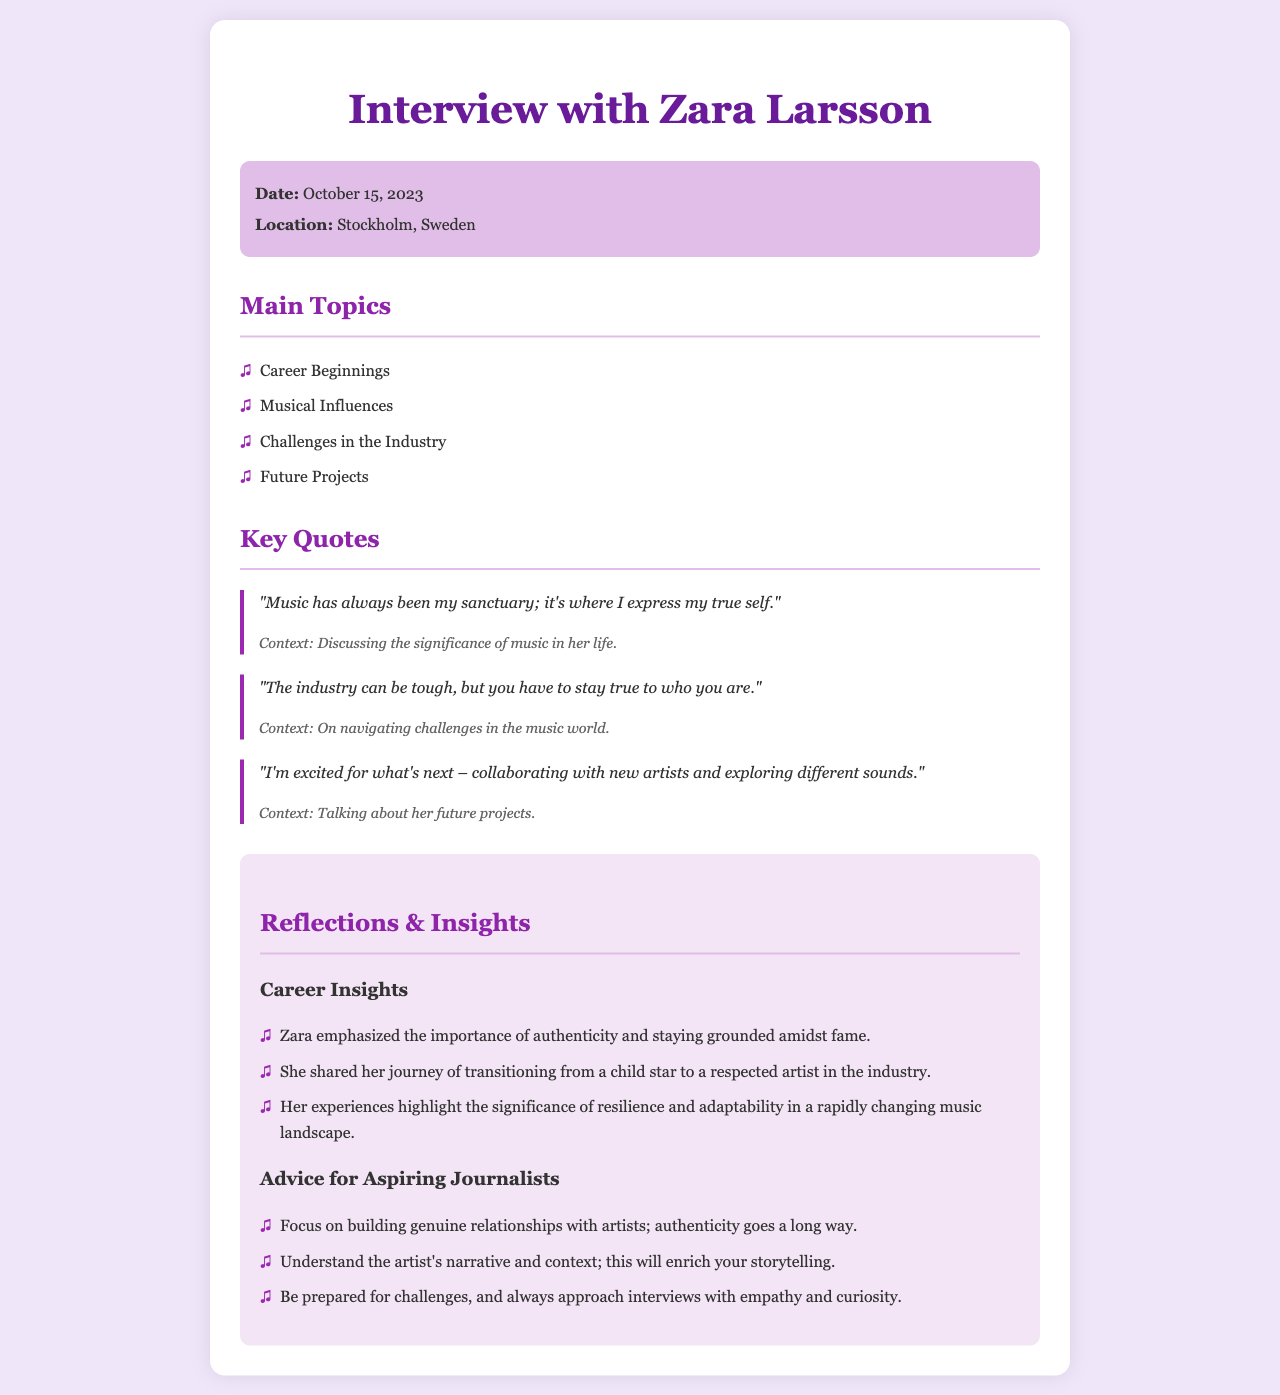What is the date of the interview? The date of the interview can be found in the document's interview details section, which states it took place on October 15, 2023.
Answer: October 15, 2023 Where was the interview conducted? The location of the interview is provided in the document, specifically noting it took place in Stockholm, Sweden.
Answer: Stockholm, Sweden What is one of the main topics discussed in the interview? The main topics are outlined in a list in the document; one of the topics is "Career Beginnings."
Answer: Career Beginnings What does Zara say about music in her life? Her view on music is captured in a quote, indicating its importance as her sanctuary and a means of self-expression.
Answer: "Music has always been my sanctuary; it's where I express my true self." What key advice does Zara give for aspiring journalists? The reflections section contains advice from Zara, emphasizing the importance of building genuine relationships with artists.
Answer: Build genuine relationships How does Zara describe the music industry? She discusses the challenges of the industry in her quotes, highlighting the need to stay true to oneself.
Answer: The industry can be tough What future projects is Zara excited about? In one of her quotes, she mentions collaborating with new artists and exploring different sounds as her upcoming interests.
Answer: Collaborating with new artists What theme is emphasized in the reflections section? The reflections highlight the theme of authenticity and resilience amidst industry challenges as emphasized by Zara.
Answer: Authenticity and resilience What is one of Zara's musical influences according to the document? The document includes a section where Zara discusses the importance of staying true to herself, indirectly implying her influences stem from various personal experiences rather than specific people.
Answer: Not directly stated 